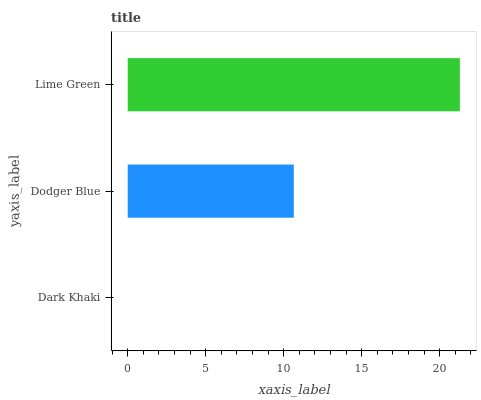Is Dark Khaki the minimum?
Answer yes or no. Yes. Is Lime Green the maximum?
Answer yes or no. Yes. Is Dodger Blue the minimum?
Answer yes or no. No. Is Dodger Blue the maximum?
Answer yes or no. No. Is Dodger Blue greater than Dark Khaki?
Answer yes or no. Yes. Is Dark Khaki less than Dodger Blue?
Answer yes or no. Yes. Is Dark Khaki greater than Dodger Blue?
Answer yes or no. No. Is Dodger Blue less than Dark Khaki?
Answer yes or no. No. Is Dodger Blue the high median?
Answer yes or no. Yes. Is Dodger Blue the low median?
Answer yes or no. Yes. Is Lime Green the high median?
Answer yes or no. No. Is Lime Green the low median?
Answer yes or no. No. 